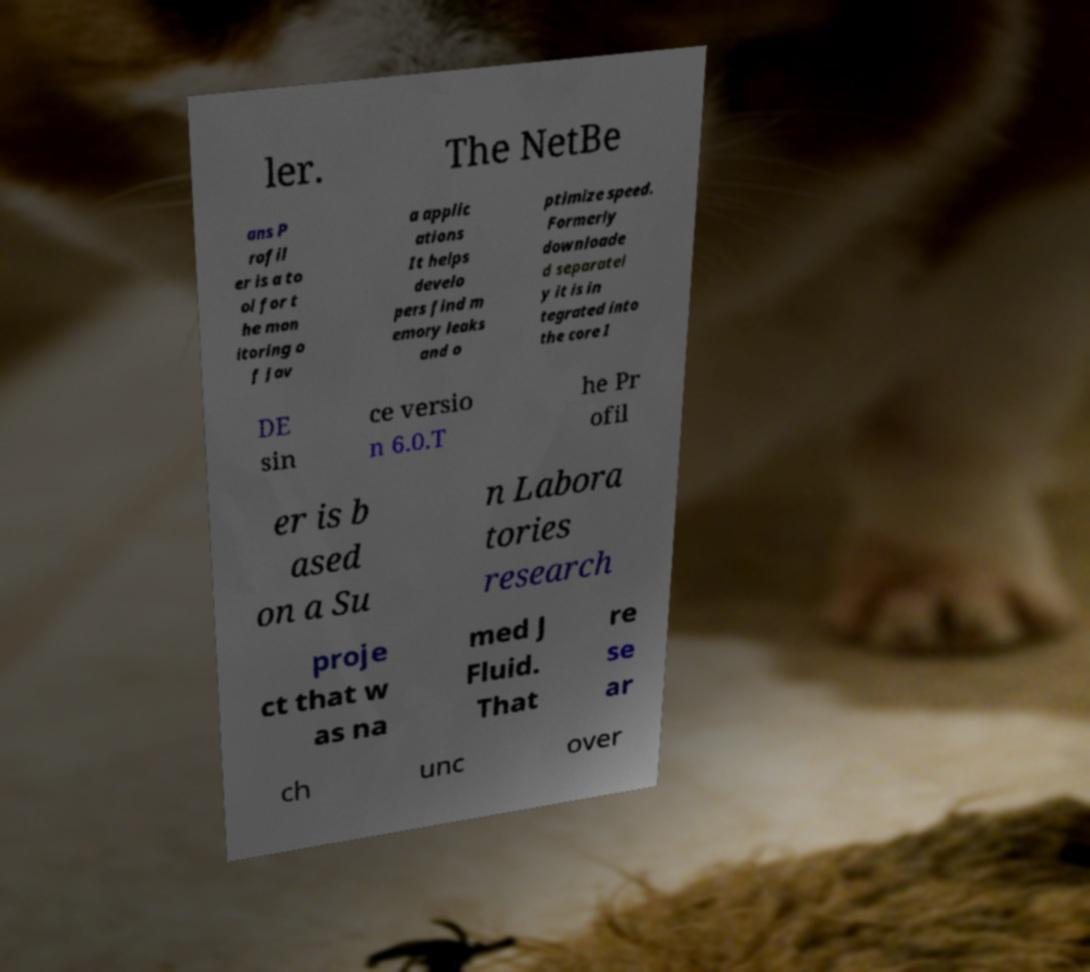What messages or text are displayed in this image? I need them in a readable, typed format. ler. The NetBe ans P rofil er is a to ol for t he mon itoring o f Jav a applic ations It helps develo pers find m emory leaks and o ptimize speed. Formerly downloade d separatel y it is in tegrated into the core I DE sin ce versio n 6.0.T he Pr ofil er is b ased on a Su n Labora tories research proje ct that w as na med J Fluid. That re se ar ch unc over 